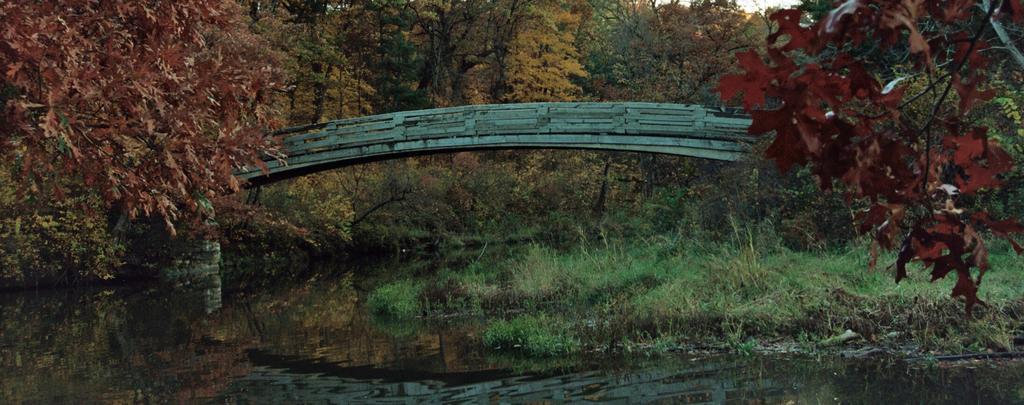Could you give a brief overview of what you see in this image? In this image I can see few trees in brown, green, yellow colors. I can see a bridge, water and the green grass. 